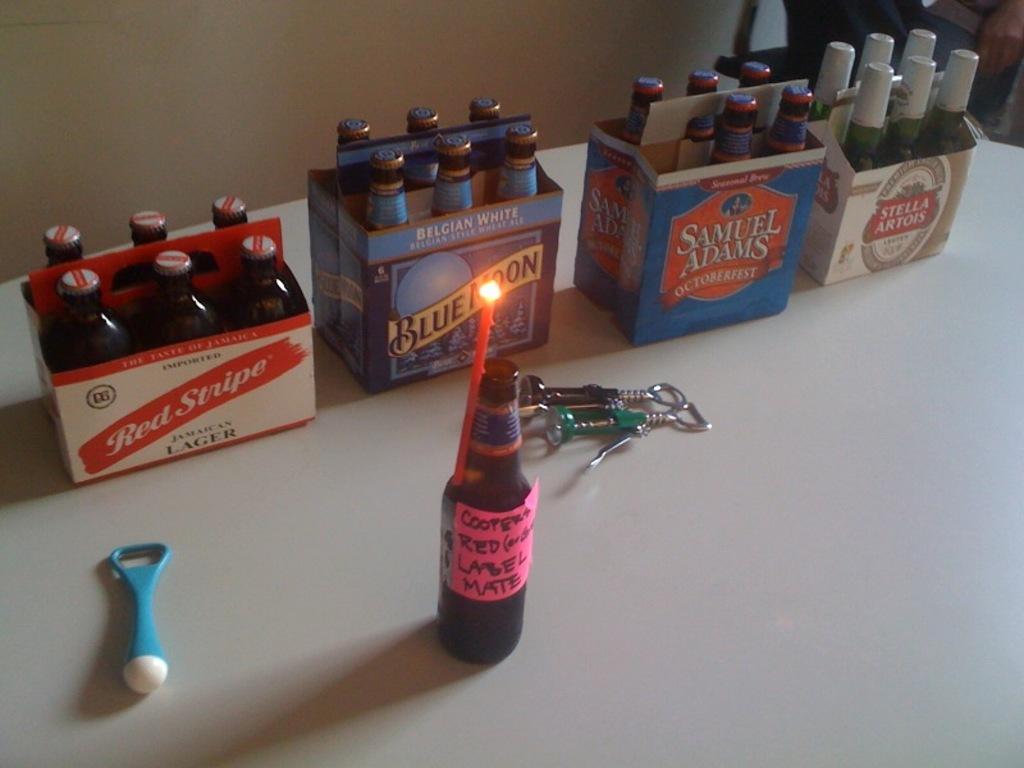What beer is to the right of blue moon?
Offer a terse response. Samuel adams. 